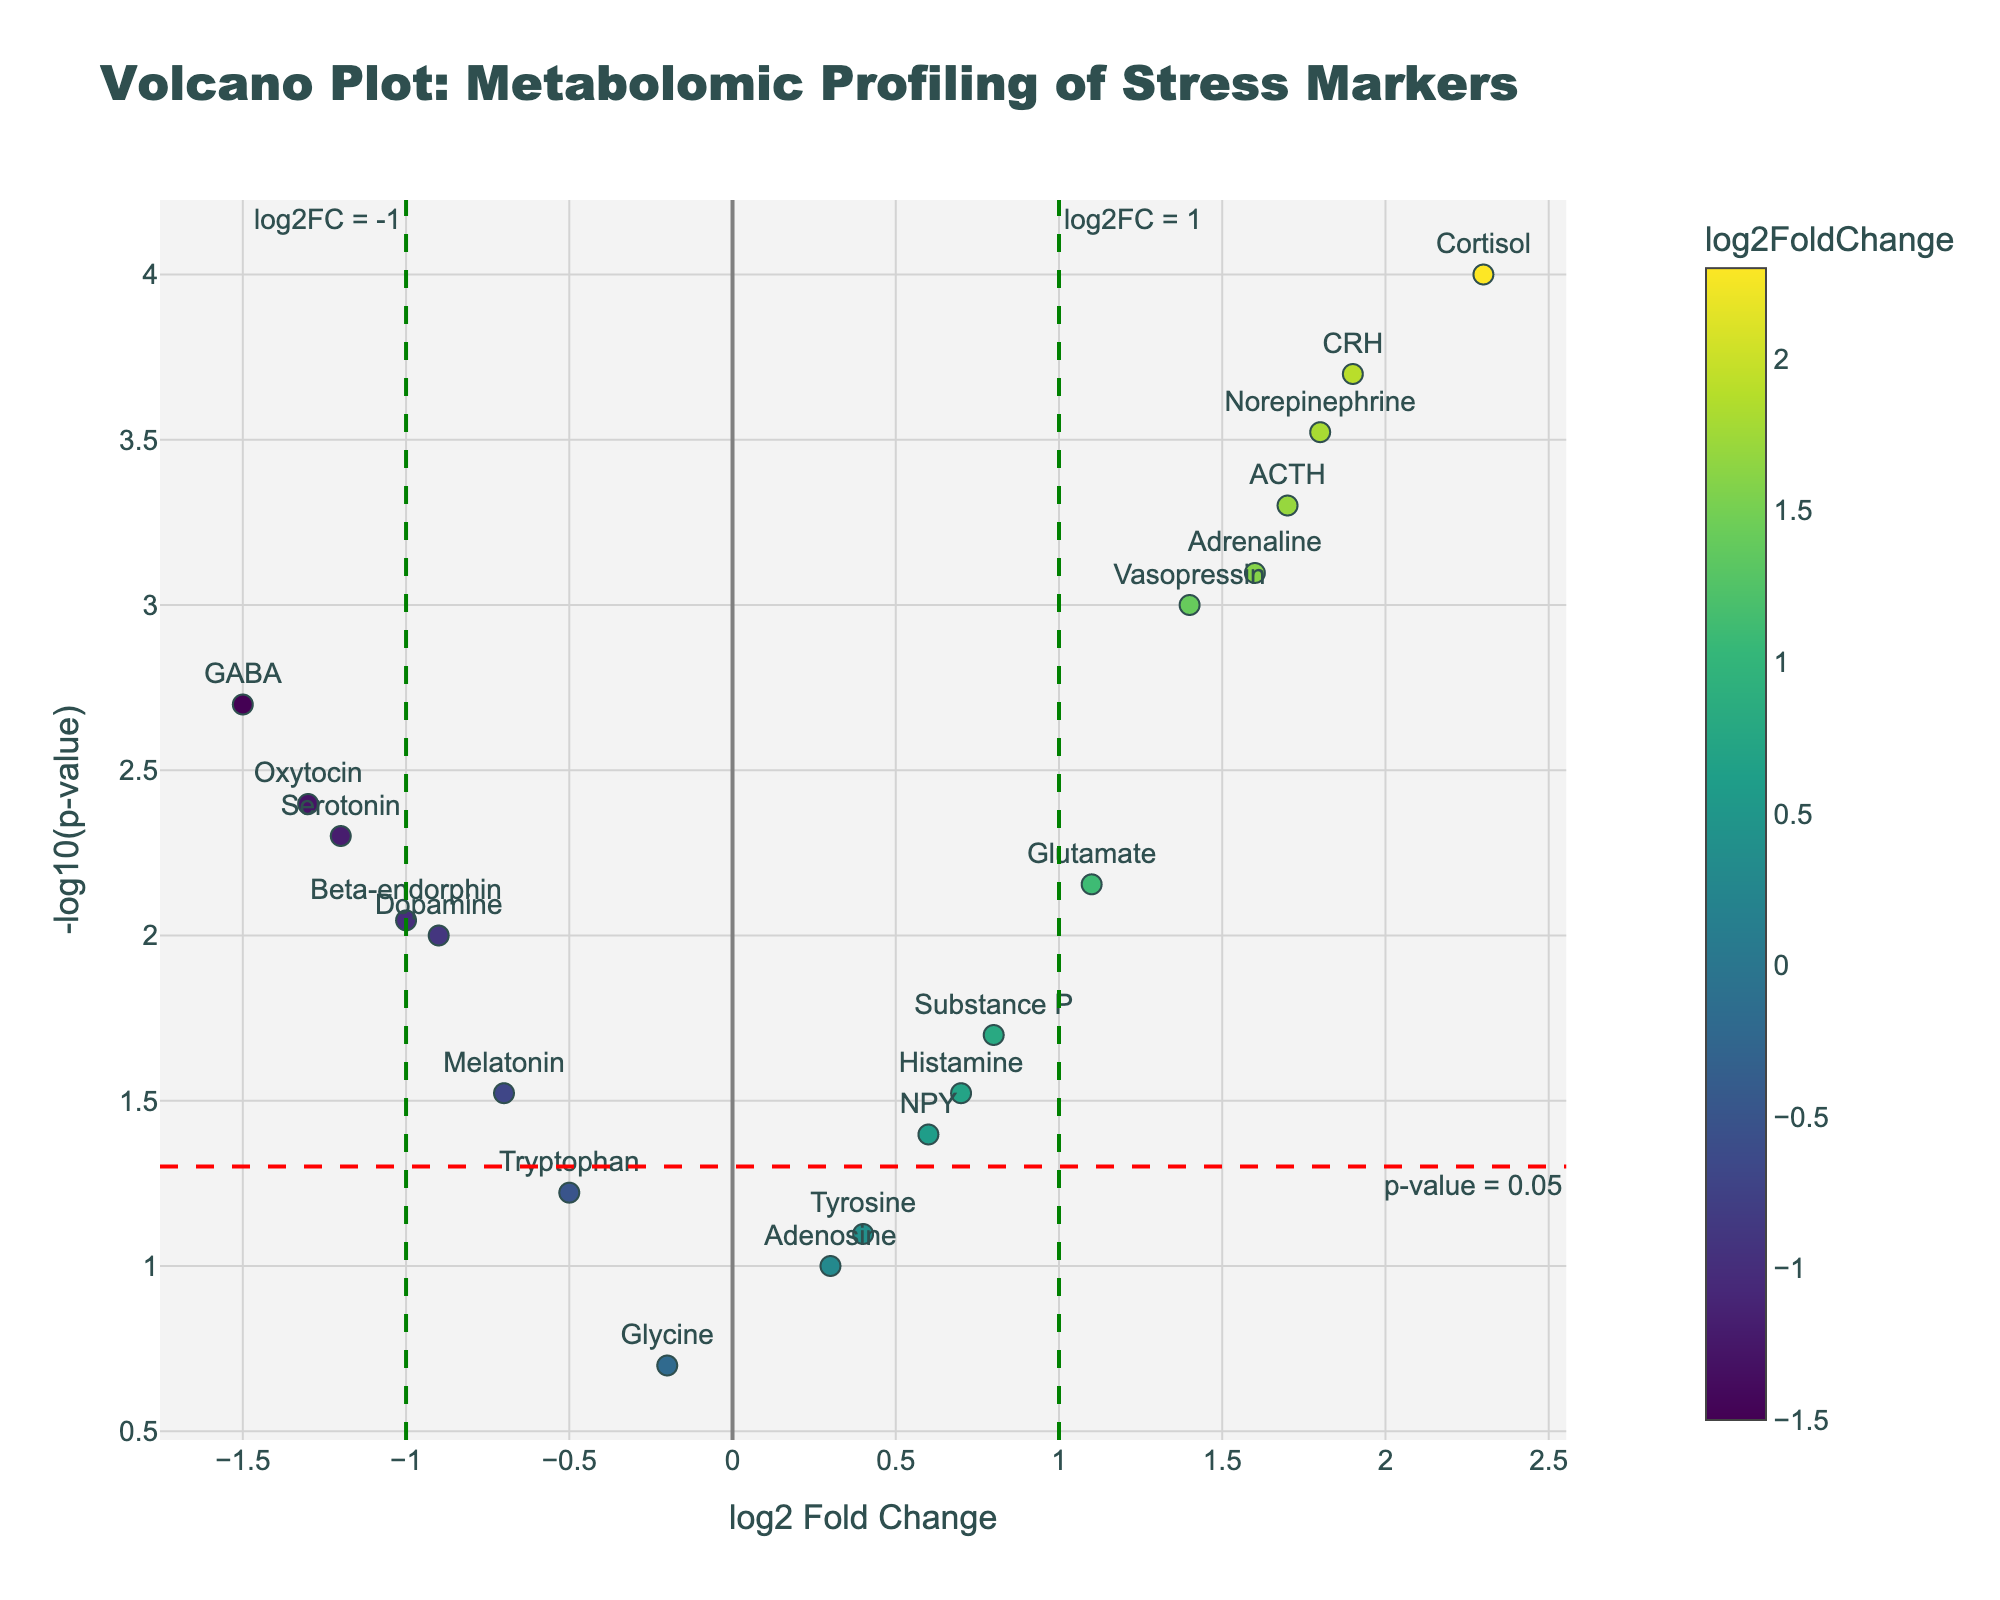How many metabolites are represented in the plot? Count the number of unique names (markers) on the plot. Each marker represents a different metabolite.
Answer: 19 Which metabolite has the highest log2FoldChange greater than 1? Identify the data point with the maximum x-value greater than 1. Check the hover text or label.
Answer: Cortisol Which metabolites show significant difference at a p-value threshold of 0.05 and a log2FoldChange threshold of ±1? Find the data points above the horizontal red line (significant p-value) and beyond the vertical green dashed lines (±1 log2FoldChange). List their names.
Answer: Cortisol, Norepinephrine, CRH, ACTH, Adrenaline What's the p-value corresponding to Serotonin? Locate Serotonin on the plot and refer to the hover text or label to find its p-value.
Answer: 0.005 How does the metabolite with log2FoldChange of 0.4 compare in terms of significance? Locate the metabolite with log2FoldChange of 0.4 (Tyrosine) and observe its position relative to the p-value threshold line.
Answer: p-value is greater than 0.05 Are there more metabolites with increased levels (positive log2FoldChange) or decreased levels (negative log2FoldChange)? Count data points with positive log2FoldChange and those with negative. Compare the counts.
Answer: More with increased levels Which metabolite lies just below the significance threshold with a p-value of around 0.04? Identify the data point close to the significance threshold line and check the hover text or label for its p-value and name.
Answer: NPY What is the range of -log10(p-value) for the plotted metabolites? Identify the minimum and maximum -log10(p-value) values from the y-axis. The lowest point is around 0.7 (Histamine/Melatonin) and the highest around 4 (Cortisol).
Answer: 0.7 to 4 Which metabolite has the smallest log2FoldChange but is still significantly different based on the p-value threshold? Find the smallest positive log2FoldChange value above the p-value threshold line by comparing data points. Look at the hover text and labels.
Answer: Histamine 